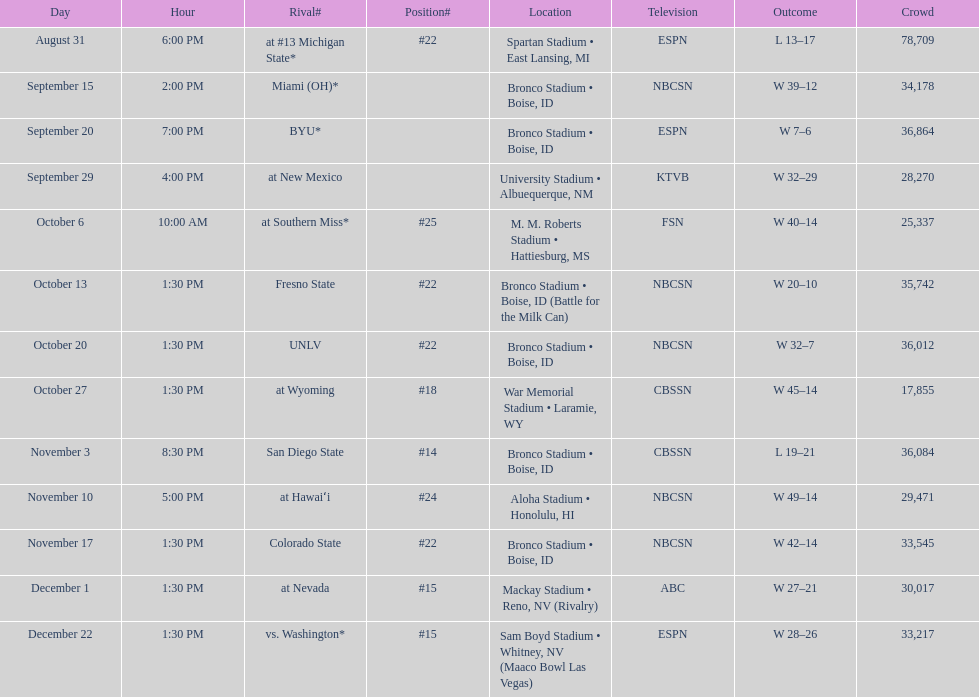Add up the total number of points scored in the last wins for boise state. 146. 